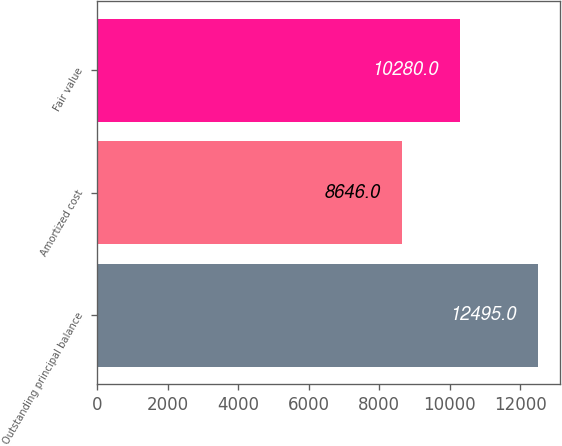<chart> <loc_0><loc_0><loc_500><loc_500><bar_chart><fcel>Outstanding principal balance<fcel>Amortized cost<fcel>Fair value<nl><fcel>12495<fcel>8646<fcel>10280<nl></chart> 